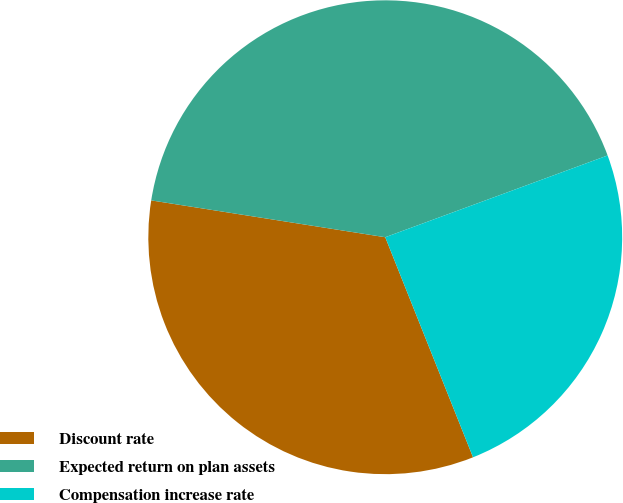<chart> <loc_0><loc_0><loc_500><loc_500><pie_chart><fcel>Discount rate<fcel>Expected return on plan assets<fcel>Compensation increase rate<nl><fcel>33.53%<fcel>41.91%<fcel>24.57%<nl></chart> 